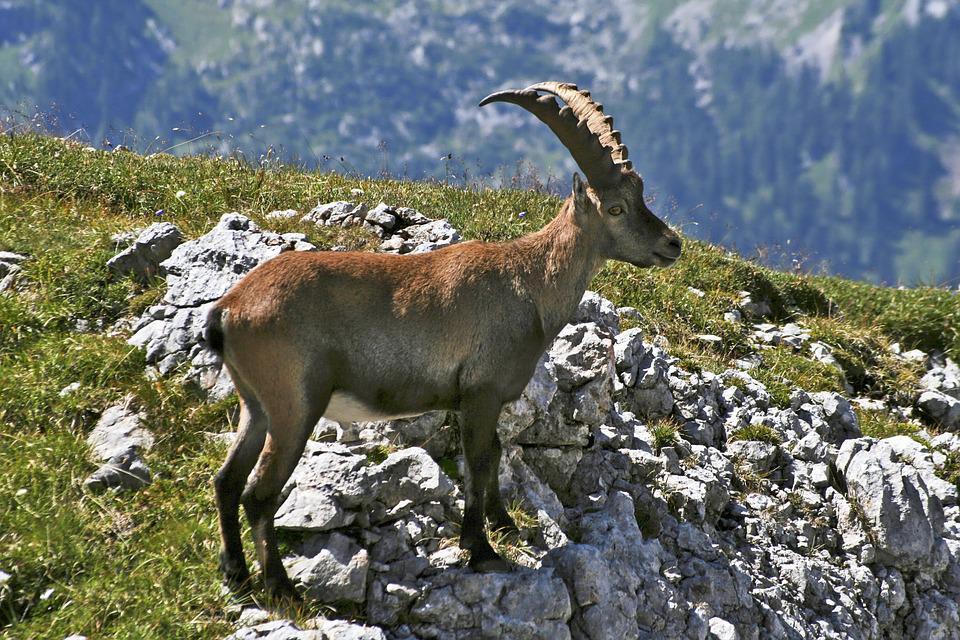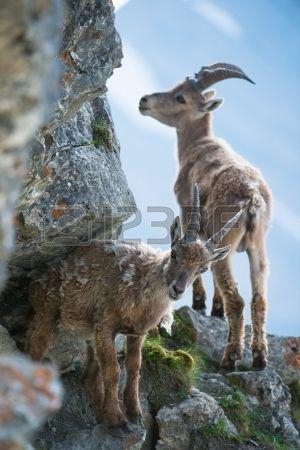The first image is the image on the left, the second image is the image on the right. Evaluate the accuracy of this statement regarding the images: "There are three goat-type animals on rocks.". Is it true? Answer yes or no. Yes. 